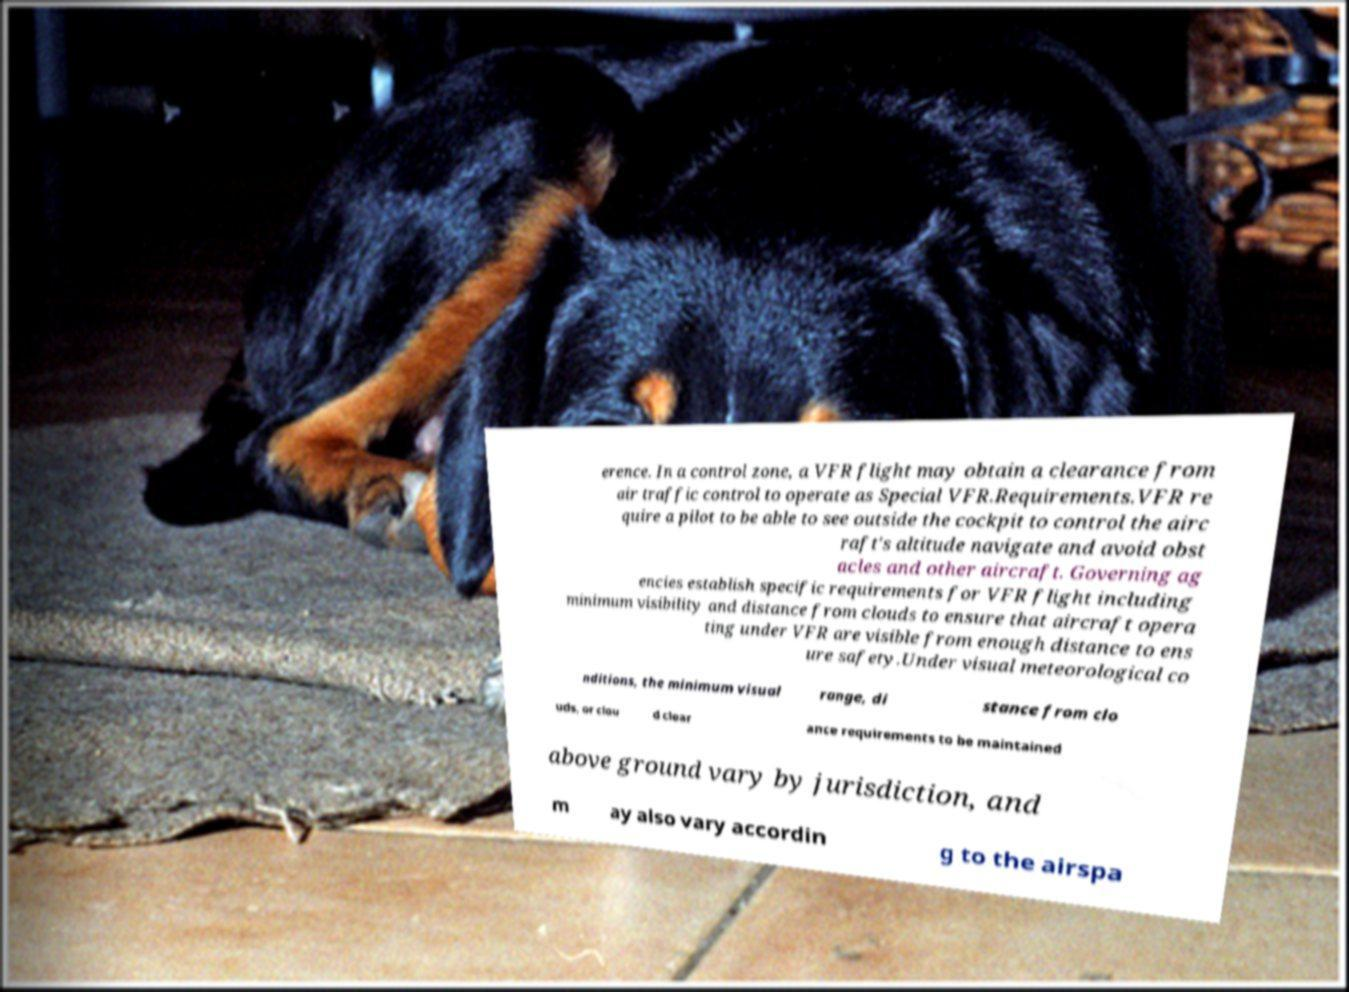Can you accurately transcribe the text from the provided image for me? erence. In a control zone, a VFR flight may obtain a clearance from air traffic control to operate as Special VFR.Requirements.VFR re quire a pilot to be able to see outside the cockpit to control the airc raft's altitude navigate and avoid obst acles and other aircraft. Governing ag encies establish specific requirements for VFR flight including minimum visibility and distance from clouds to ensure that aircraft opera ting under VFR are visible from enough distance to ens ure safety.Under visual meteorological co nditions, the minimum visual range, di stance from clo uds, or clou d clear ance requirements to be maintained above ground vary by jurisdiction, and m ay also vary accordin g to the airspa 